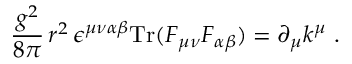Convert formula to latex. <formula><loc_0><loc_0><loc_500><loc_500>\frac { g ^ { 2 } } { 8 \pi } \, r ^ { 2 } \, \epsilon ^ { \mu \nu \alpha \beta } T r ( F _ { \mu \nu } F _ { \alpha \beta } ) = \partial _ { \mu } k ^ { \mu } \ .</formula> 